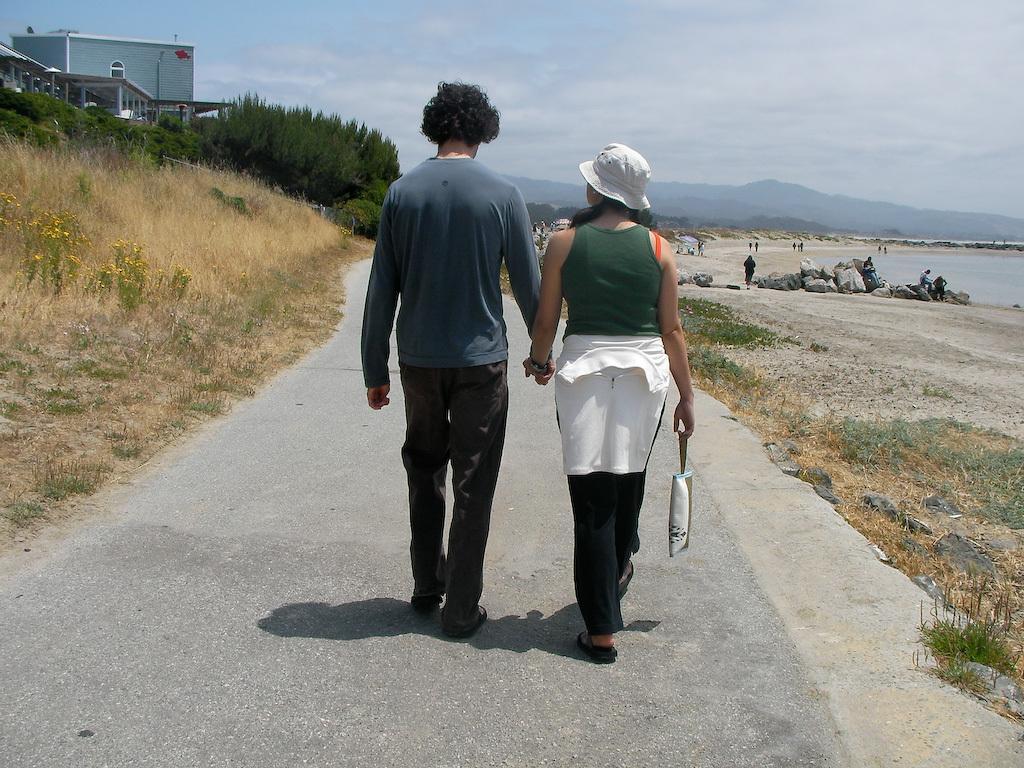In one or two sentences, can you explain what this image depicts? In this image in the center there are two persons who are holding hands and walking, and on the left side there is some grass and trees houses. At the bottom there is a road, and on the right side there is a beach and some persons are walking. And also there is some grass and some small stones. In the background there are some mountains, and at the top of the image there is sky. 